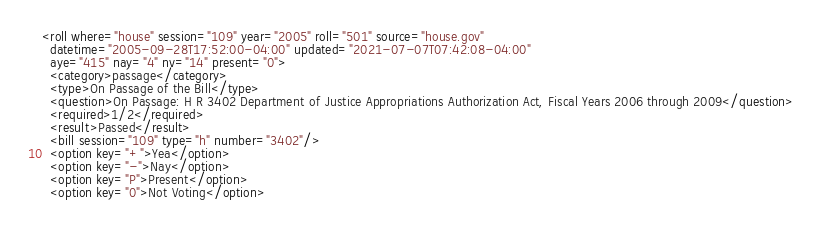<code> <loc_0><loc_0><loc_500><loc_500><_XML_><roll where="house" session="109" year="2005" roll="501" source="house.gov"
  datetime="2005-09-28T17:52:00-04:00" updated="2021-07-07T07:42:08-04:00"
  aye="415" nay="4" nv="14" present="0">
  <category>passage</category>
  <type>On Passage of the Bill</type>
  <question>On Passage: H R 3402 Department of Justice Appropriations Authorization Act, Fiscal Years 2006 through 2009</question>
  <required>1/2</required>
  <result>Passed</result>
  <bill session="109" type="h" number="3402"/>
  <option key="+">Yea</option>
  <option key="-">Nay</option>
  <option key="P">Present</option>
  <option key="0">Not Voting</option></code> 